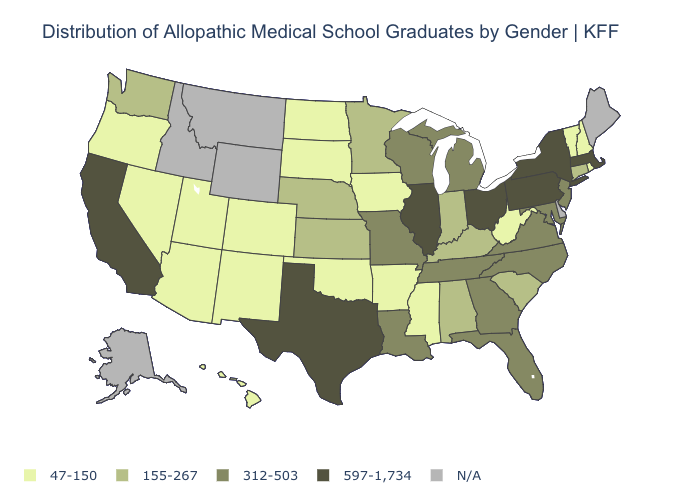What is the value of Iowa?
Answer briefly. 47-150. Name the states that have a value in the range N/A?
Keep it brief. Alaska, Delaware, Idaho, Maine, Montana, Wyoming. What is the value of Utah?
Quick response, please. 47-150. What is the value of Alabama?
Keep it brief. 155-267. Among the states that border Nebraska , does South Dakota have the highest value?
Short answer required. No. Does South Dakota have the highest value in the USA?
Be succinct. No. Does Alabama have the lowest value in the USA?
Answer briefly. No. Name the states that have a value in the range 597-1,734?
Be succinct. California, Illinois, Massachusetts, New York, Ohio, Pennsylvania, Texas. What is the value of Virginia?
Answer briefly. 312-503. Name the states that have a value in the range 312-503?
Answer briefly. Florida, Georgia, Louisiana, Maryland, Michigan, Missouri, New Jersey, North Carolina, Tennessee, Virginia, Wisconsin. What is the highest value in the USA?
Quick response, please. 597-1,734. What is the value of Arkansas?
Give a very brief answer. 47-150. Name the states that have a value in the range 155-267?
Answer briefly. Alabama, Connecticut, Indiana, Kansas, Kentucky, Minnesota, Nebraska, South Carolina, Washington. Name the states that have a value in the range 597-1,734?
Write a very short answer. California, Illinois, Massachusetts, New York, Ohio, Pennsylvania, Texas. 